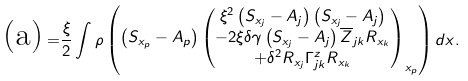<formula> <loc_0><loc_0><loc_500><loc_500>\text {(a)} = & \frac { \xi } { 2 } \int \rho \begin{pmatrix} \left ( S _ { x _ { p } } - A _ { p } \right ) \begin{pmatrix} \xi ^ { 2 } \left ( S _ { x _ { j } } - A _ { j } \right ) \left ( S _ { x _ { j } } - A _ { j } \right ) \\ - 2 \xi \delta \gamma \left ( S _ { x _ { j } } - A _ { j } \right ) \overline { Z } _ { j k } R _ { x _ { k } } \\ + \delta ^ { 2 } R _ { x _ { j } } \Gamma ^ { z } _ { j k } R _ { x _ { k } } \end{pmatrix} _ { x _ { p } } \end{pmatrix} d x .</formula> 